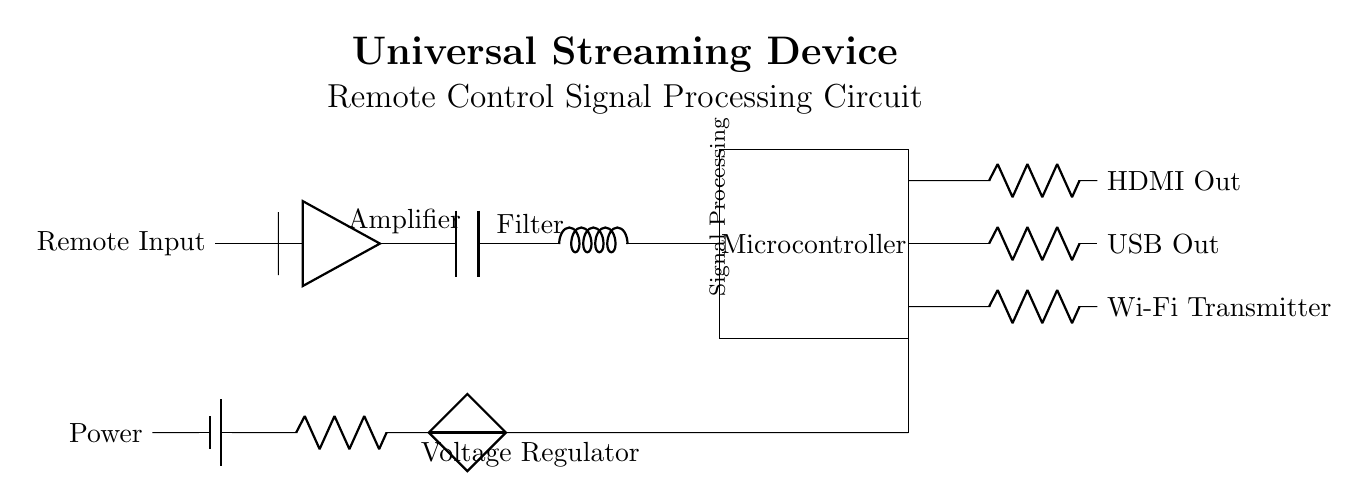What component is used for signal amplification? The diagram shows an "Amplifier" component, which is specifically identified in the circuit. It is directly connected to the input signal and filters, confirming its role as a signal amplifier.
Answer: Amplifier What is the purpose of the filter in this circuit? The "Filter" component in the diagram is intended to process the amplified signal, allowing certain frequencies to pass while attenuating others, thus improving the quality of the signal before it reaches the microcontroller.
Answer: Signal processing How many output stages are present in the circuit? The circuit has three output stages as indicated by the connections leading to HDMI Out, USB Out, and Wi-Fi Transmitter. Each output stage connects from the microcontroller and performs a distinct function.
Answer: Three What is the function of the microcontroller in this circuit? The "Microcontroller" is labeled as the part responsible for "Signal Processing," which includes interpreting and managing the input signals to control the output accordingly. It serves as the brain of the circuit, processing information.
Answer: Signal processing What type of voltage regulation is shown in this circuit? The circuit includes a "Voltage Regulator," which is used to maintain a constant output voltage despite variations in the input voltage or load conditions. It ensures the circuit components receive stable power for proper functionality.
Answer: Voltage regulation 